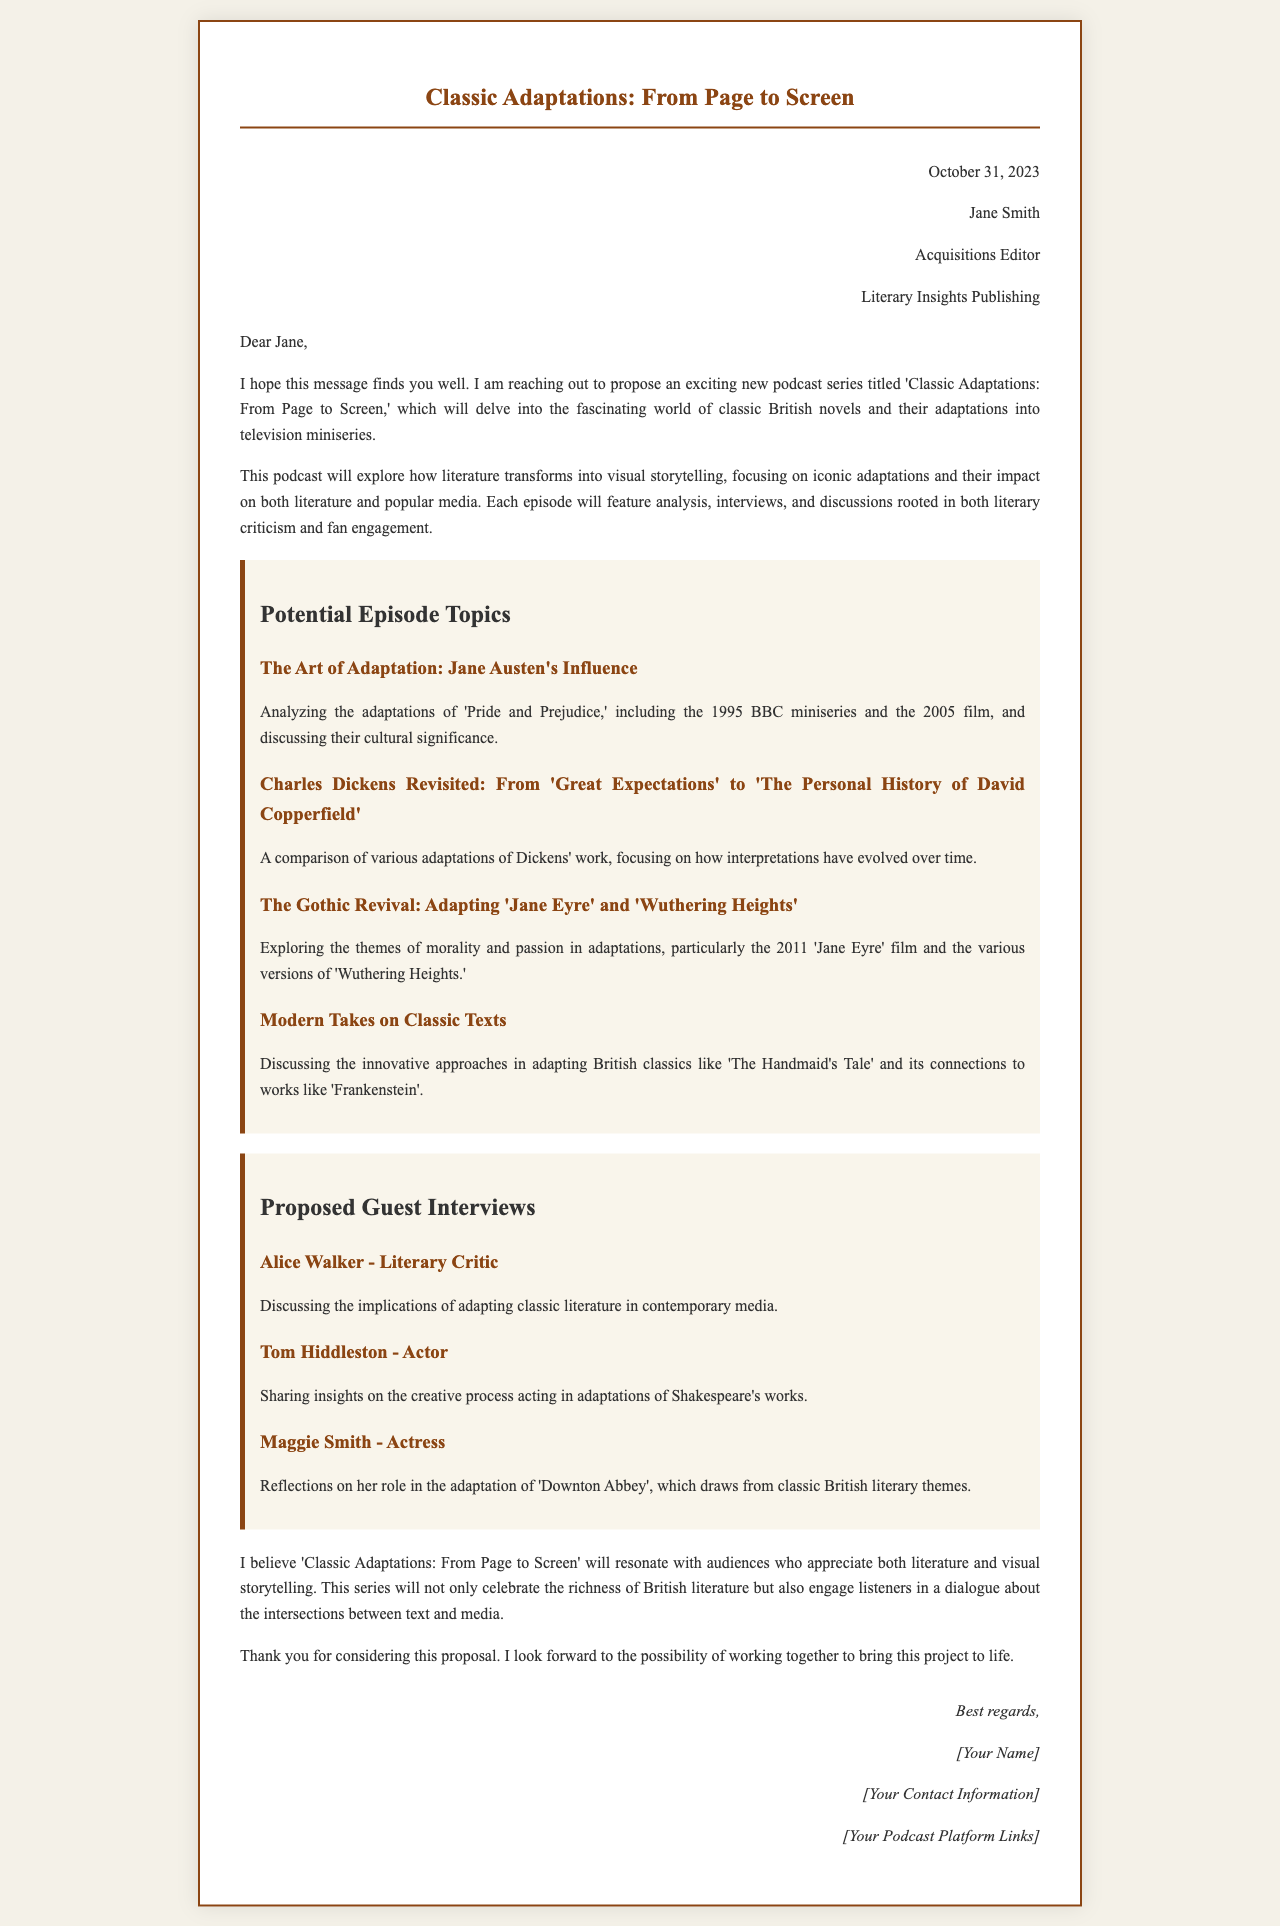What is the title of the podcast series? The title of the podcast series mentioned in the letter is 'Classic Adaptations: From Page to Screen.'
Answer: Classic Adaptations: From Page to Screen Who is the proposed guest known as a literary critic? The document lists Alice Walker as the proposed guest known for her role as a literary critic.
Answer: Alice Walker What is the date mentioned in the addressed portion of the letter? The date provided in the letter is October 31, 2023.
Answer: October 31, 2023 Which classic author is featured in the episode topic about adaptations of 'Pride and Prejudice'? The episode topic discussing 'Pride and Prejudice' focuses on the author Jane Austen.
Answer: Jane Austen How many potential episode topics are listed in the document? There are a total of four potential episode topics listed in the document.
Answer: 4 What adaptation is specifically mentioned in relation to Charles Dickens? The adaptation specifically mentioned in relation to Charles Dickens is 'Great Expectations'.
Answer: Great Expectations What does the podcast aim to explore according to the introduction? The podcast aims to explore how literature transforms into visual storytelling.
Answer: Visual storytelling Who is the actress proposed to discuss her role in 'Downton Abbey'? The actress proposed to discuss her role in 'Downton Abbey' is Maggie Smith.
Answer: Maggie Smith 